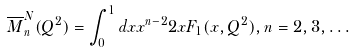<formula> <loc_0><loc_0><loc_500><loc_500>\overline { M } _ { n } ^ { N } ( Q ^ { 2 } ) = \int _ { 0 } ^ { 1 } d x x ^ { n - 2 } 2 x F _ { 1 } ( x , Q ^ { 2 } ) , n = 2 , 3 , \dots</formula> 